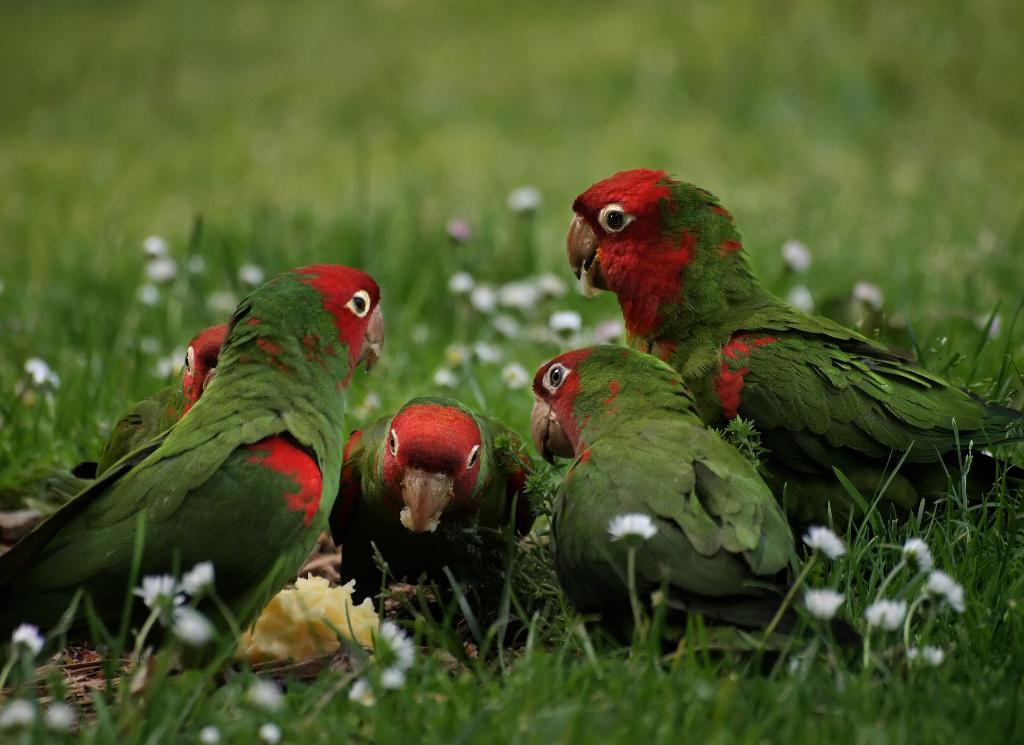What type of animals are in the image? There are parrots in the image. What colors are the parrots? The parrots are in green and red colors. What are the parrots doing in the image? The parrots are eating. What type of vegetation is at the bottom of the image? There is green grass at the bottom of the image. How would you describe the background of the image? The background of the image is blurred. What type of railway can be seen in the image? There is no railway present in the image; it features parrots eating and green grass at the bottom. 